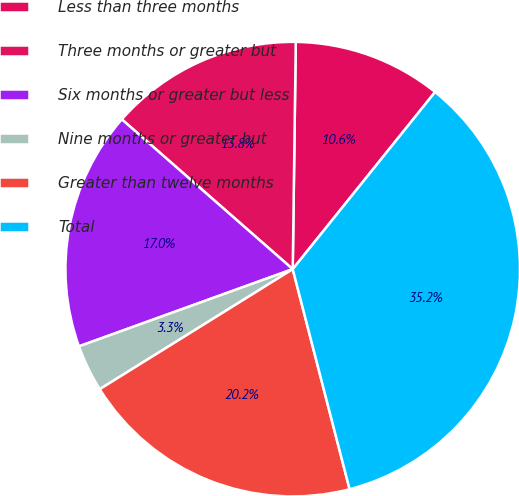Convert chart. <chart><loc_0><loc_0><loc_500><loc_500><pie_chart><fcel>Less than three months<fcel>Three months or greater but<fcel>Six months or greater but less<fcel>Nine months or greater but<fcel>Greater than twelve months<fcel>Total<nl><fcel>10.56%<fcel>13.76%<fcel>16.97%<fcel>3.34%<fcel>20.17%<fcel>35.2%<nl></chart> 